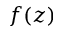<formula> <loc_0><loc_0><loc_500><loc_500>f ( z )</formula> 